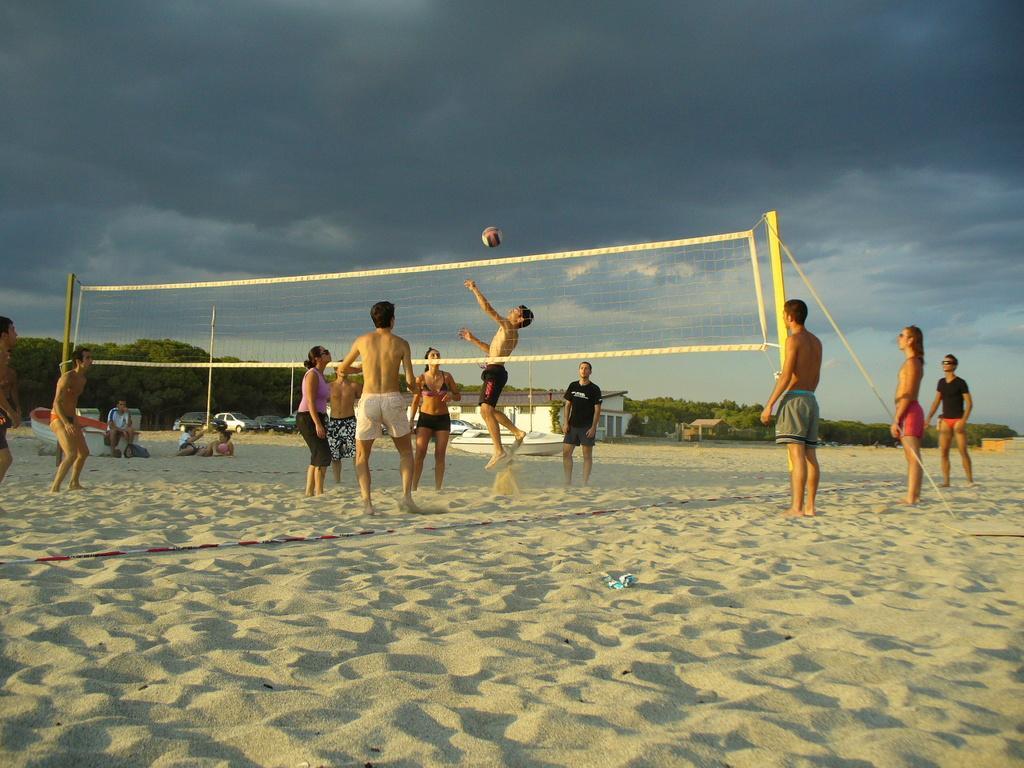Can you describe this image briefly? In this picture I can see the sand on which there are few people who are standing and I can see a man who is jumping and I can see 2 poles on which there is a net. I can also see a ball in the center of this picture. On the left side of this picture I can see few of them are sitting. In the background I can see few boats, cars, a buildings, number of trees and the cloudy sky. 